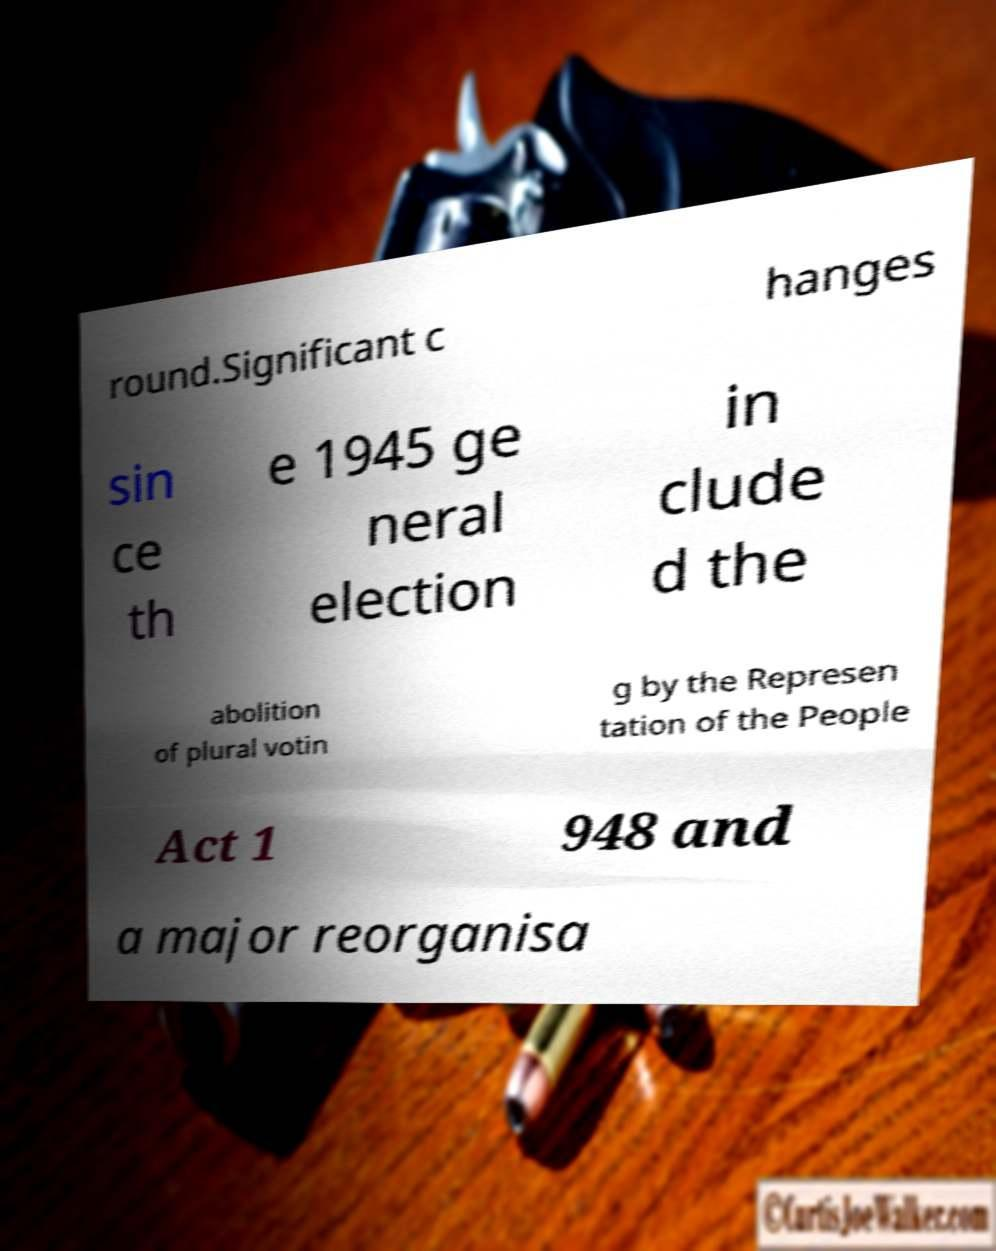Please identify and transcribe the text found in this image. round.Significant c hanges sin ce th e 1945 ge neral election in clude d the abolition of plural votin g by the Represen tation of the People Act 1 948 and a major reorganisa 